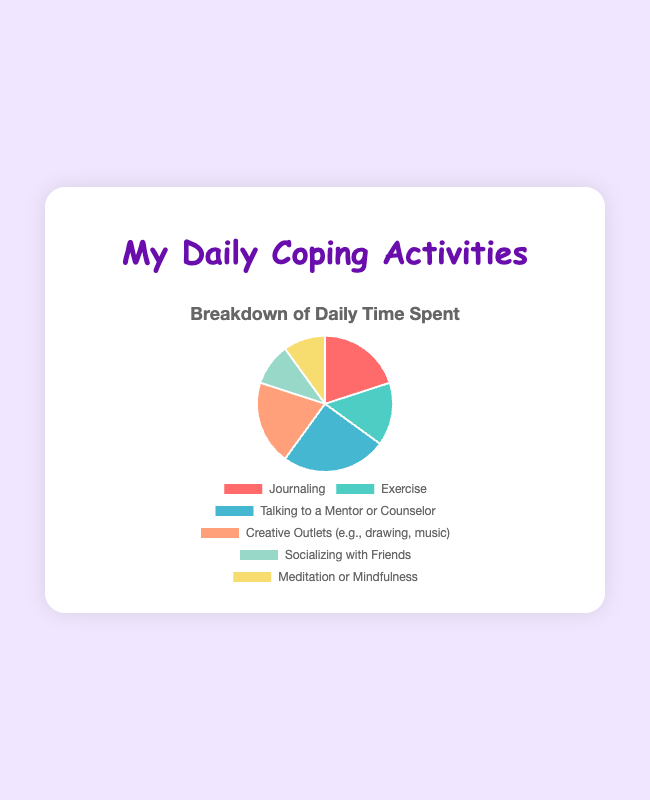What's the total percentage of time spent on creative outlets and journaling together? Add the percentage for Creative Outlets (20%) and Journaling (20%). 20% + 20% = 40%
Answer: 40% Which activity has the highest percentage of time spent? The percentage values for each activity are compared, and Talking to a Mentor or Counselor has the highest percentage at 25%
Answer: Talking to a Mentor or Counselor How much more time do you spend on talking to a mentor or counselor compared to socializing with friends? Talking to a Mentor or Counselor is 25%, and Socializing with Friends is 10%. 25% - 10% = 15%
Answer: 15% Are there any activities that take up an equal amount of time? Which ones? Both Journaling and Creative Outlets take up 20% of time each, and both Socializing with Friends and Meditation or Mindfulness take up 10% of time each
Answer: Journaling and Creative Outlets; Socializing with Friends and Meditation or Mindfulness What's the average percentage of time spent on all activities? Sum all the percentages: 20% + 15% + 25% + 20% + 10% + 10% = 100%. Divide by the number of activities, 100% / 6 ≈ 16.67%
Answer: 16.67% Which activities are done less frequently than exercise? Exercise takes up 15%. Activities that take up less time are Socializing with Friends (10%) and Meditation or Mindfulness (10%)
Answer: Socializing with Friends, Meditation or Mindfulness What is the combined percentage of time spent on meditation, mindfulness, and socializing with friends? Meditation or Mindfulness is 10%, and Socializing with Friends is 10%. 10% + 10% = 20%
Answer: 20% Which activity takes up the smallest portion of time? Socializing with Friends and Meditation or Mindfulness both take up 10%, which is the smallest portion
Answer: Socializing with Friends, Meditation or Mindfulness What is the difference in the percentage of time spent on exercise and journaling? Journaling is 20%, and Exercise is 15%. 20% - 15% = 5%
Answer: 5% Is more time spent on talking to a mentor or counselor than on journaling and meditation combined? Talking to a Mentor or Counselor is 25%. Journaling is 20%, and Meditation or Mindfulness is 10%. 20% + 10% = 30%, which is greater than 25%
Answer: No 